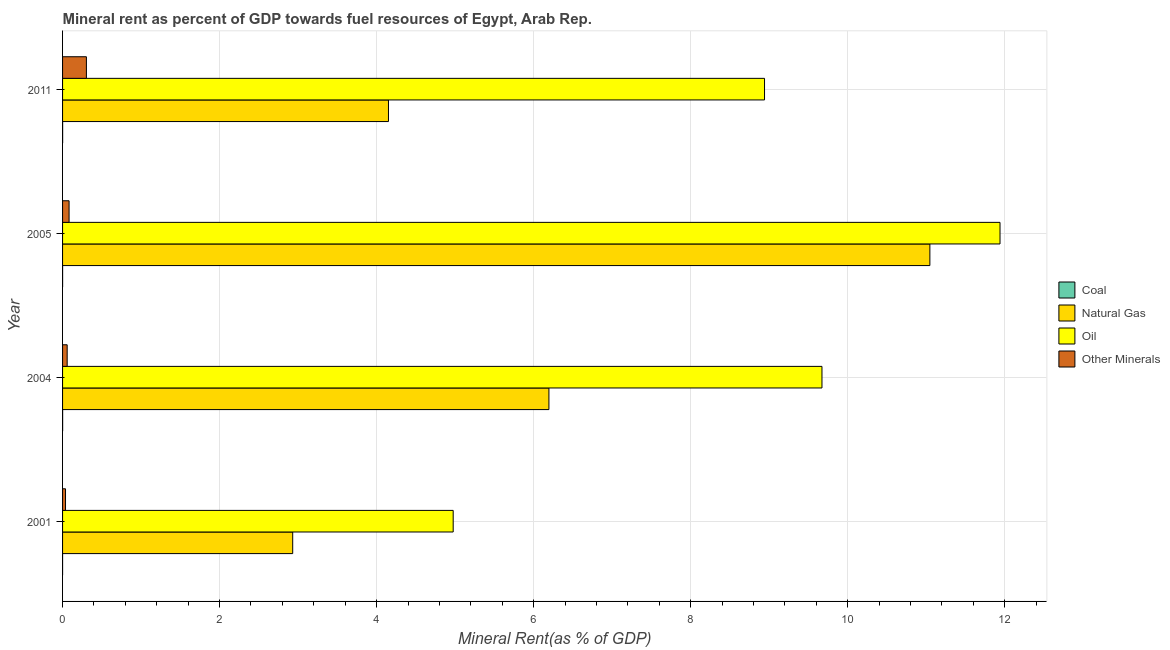How many different coloured bars are there?
Your response must be concise. 4. Are the number of bars per tick equal to the number of legend labels?
Make the answer very short. Yes. Are the number of bars on each tick of the Y-axis equal?
Offer a terse response. Yes. In how many cases, is the number of bars for a given year not equal to the number of legend labels?
Your answer should be compact. 0. What is the  rent of other minerals in 2004?
Offer a very short reply. 0.06. Across all years, what is the maximum natural gas rent?
Your answer should be compact. 11.05. Across all years, what is the minimum oil rent?
Give a very brief answer. 4.98. In which year was the natural gas rent minimum?
Offer a very short reply. 2001. What is the total oil rent in the graph?
Your response must be concise. 35.53. What is the difference between the coal rent in 2001 and that in 2011?
Make the answer very short. -0. What is the difference between the  rent of other minerals in 2001 and the natural gas rent in 2011?
Your response must be concise. -4.11. What is the average coal rent per year?
Your answer should be very brief. 0. In the year 2011, what is the difference between the coal rent and natural gas rent?
Give a very brief answer. -4.15. In how many years, is the coal rent greater than 9.2 %?
Your answer should be very brief. 0. What is the ratio of the  rent of other minerals in 2004 to that in 2011?
Make the answer very short. 0.19. Is the oil rent in 2004 less than that in 2005?
Your answer should be compact. Yes. What is the difference between the highest and the second highest natural gas rent?
Make the answer very short. 4.85. What does the 1st bar from the top in 2011 represents?
Make the answer very short. Other Minerals. What does the 1st bar from the bottom in 2001 represents?
Keep it short and to the point. Coal. How many bars are there?
Give a very brief answer. 16. What is the difference between two consecutive major ticks on the X-axis?
Your response must be concise. 2. Does the graph contain any zero values?
Your answer should be very brief. No. Does the graph contain grids?
Keep it short and to the point. Yes. How many legend labels are there?
Provide a short and direct response. 4. What is the title of the graph?
Make the answer very short. Mineral rent as percent of GDP towards fuel resources of Egypt, Arab Rep. Does "Secondary vocational education" appear as one of the legend labels in the graph?
Your answer should be very brief. No. What is the label or title of the X-axis?
Keep it short and to the point. Mineral Rent(as % of GDP). What is the label or title of the Y-axis?
Offer a terse response. Year. What is the Mineral Rent(as % of GDP) of Coal in 2001?
Provide a short and direct response. 1.02739128441411e-6. What is the Mineral Rent(as % of GDP) of Natural Gas in 2001?
Offer a terse response. 2.93. What is the Mineral Rent(as % of GDP) in Oil in 2001?
Ensure brevity in your answer.  4.98. What is the Mineral Rent(as % of GDP) in Other Minerals in 2001?
Keep it short and to the point. 0.04. What is the Mineral Rent(as % of GDP) in Coal in 2004?
Provide a short and direct response. 0. What is the Mineral Rent(as % of GDP) in Natural Gas in 2004?
Offer a very short reply. 6.19. What is the Mineral Rent(as % of GDP) in Oil in 2004?
Offer a terse response. 9.67. What is the Mineral Rent(as % of GDP) of Other Minerals in 2004?
Your answer should be very brief. 0.06. What is the Mineral Rent(as % of GDP) of Coal in 2005?
Your answer should be very brief. 0. What is the Mineral Rent(as % of GDP) in Natural Gas in 2005?
Provide a short and direct response. 11.05. What is the Mineral Rent(as % of GDP) in Oil in 2005?
Provide a succinct answer. 11.94. What is the Mineral Rent(as % of GDP) in Other Minerals in 2005?
Your answer should be very brief. 0.08. What is the Mineral Rent(as % of GDP) in Coal in 2011?
Make the answer very short. 0. What is the Mineral Rent(as % of GDP) of Natural Gas in 2011?
Your answer should be very brief. 4.15. What is the Mineral Rent(as % of GDP) of Oil in 2011?
Keep it short and to the point. 8.94. What is the Mineral Rent(as % of GDP) in Other Minerals in 2011?
Provide a succinct answer. 0.3. Across all years, what is the maximum Mineral Rent(as % of GDP) of Coal?
Offer a terse response. 0. Across all years, what is the maximum Mineral Rent(as % of GDP) in Natural Gas?
Make the answer very short. 11.05. Across all years, what is the maximum Mineral Rent(as % of GDP) in Oil?
Give a very brief answer. 11.94. Across all years, what is the maximum Mineral Rent(as % of GDP) of Other Minerals?
Your response must be concise. 0.3. Across all years, what is the minimum Mineral Rent(as % of GDP) of Coal?
Your answer should be compact. 1.02739128441411e-6. Across all years, what is the minimum Mineral Rent(as % of GDP) in Natural Gas?
Offer a very short reply. 2.93. Across all years, what is the minimum Mineral Rent(as % of GDP) of Oil?
Your answer should be compact. 4.98. Across all years, what is the minimum Mineral Rent(as % of GDP) in Other Minerals?
Provide a short and direct response. 0.04. What is the total Mineral Rent(as % of GDP) in Coal in the graph?
Provide a succinct answer. 0. What is the total Mineral Rent(as % of GDP) in Natural Gas in the graph?
Offer a terse response. 24.32. What is the total Mineral Rent(as % of GDP) in Oil in the graph?
Give a very brief answer. 35.53. What is the total Mineral Rent(as % of GDP) of Other Minerals in the graph?
Ensure brevity in your answer.  0.48. What is the difference between the Mineral Rent(as % of GDP) of Coal in 2001 and that in 2004?
Keep it short and to the point. -0. What is the difference between the Mineral Rent(as % of GDP) of Natural Gas in 2001 and that in 2004?
Your answer should be very brief. -3.26. What is the difference between the Mineral Rent(as % of GDP) in Oil in 2001 and that in 2004?
Make the answer very short. -4.7. What is the difference between the Mineral Rent(as % of GDP) in Other Minerals in 2001 and that in 2004?
Your answer should be very brief. -0.02. What is the difference between the Mineral Rent(as % of GDP) in Coal in 2001 and that in 2005?
Offer a very short reply. -0. What is the difference between the Mineral Rent(as % of GDP) in Natural Gas in 2001 and that in 2005?
Provide a short and direct response. -8.12. What is the difference between the Mineral Rent(as % of GDP) of Oil in 2001 and that in 2005?
Make the answer very short. -6.96. What is the difference between the Mineral Rent(as % of GDP) in Other Minerals in 2001 and that in 2005?
Offer a very short reply. -0.05. What is the difference between the Mineral Rent(as % of GDP) in Coal in 2001 and that in 2011?
Your answer should be very brief. -0. What is the difference between the Mineral Rent(as % of GDP) in Natural Gas in 2001 and that in 2011?
Make the answer very short. -1.22. What is the difference between the Mineral Rent(as % of GDP) in Oil in 2001 and that in 2011?
Give a very brief answer. -3.97. What is the difference between the Mineral Rent(as % of GDP) of Other Minerals in 2001 and that in 2011?
Your response must be concise. -0.27. What is the difference between the Mineral Rent(as % of GDP) of Coal in 2004 and that in 2005?
Your answer should be compact. 0. What is the difference between the Mineral Rent(as % of GDP) in Natural Gas in 2004 and that in 2005?
Your answer should be very brief. -4.85. What is the difference between the Mineral Rent(as % of GDP) of Oil in 2004 and that in 2005?
Ensure brevity in your answer.  -2.27. What is the difference between the Mineral Rent(as % of GDP) in Other Minerals in 2004 and that in 2005?
Keep it short and to the point. -0.02. What is the difference between the Mineral Rent(as % of GDP) in Natural Gas in 2004 and that in 2011?
Offer a very short reply. 2.04. What is the difference between the Mineral Rent(as % of GDP) of Oil in 2004 and that in 2011?
Your answer should be very brief. 0.73. What is the difference between the Mineral Rent(as % of GDP) in Other Minerals in 2004 and that in 2011?
Your answer should be compact. -0.24. What is the difference between the Mineral Rent(as % of GDP) in Coal in 2005 and that in 2011?
Your response must be concise. -0. What is the difference between the Mineral Rent(as % of GDP) of Natural Gas in 2005 and that in 2011?
Provide a succinct answer. 6.9. What is the difference between the Mineral Rent(as % of GDP) of Oil in 2005 and that in 2011?
Your response must be concise. 3. What is the difference between the Mineral Rent(as % of GDP) of Other Minerals in 2005 and that in 2011?
Give a very brief answer. -0.22. What is the difference between the Mineral Rent(as % of GDP) in Coal in 2001 and the Mineral Rent(as % of GDP) in Natural Gas in 2004?
Give a very brief answer. -6.19. What is the difference between the Mineral Rent(as % of GDP) of Coal in 2001 and the Mineral Rent(as % of GDP) of Oil in 2004?
Offer a terse response. -9.67. What is the difference between the Mineral Rent(as % of GDP) of Coal in 2001 and the Mineral Rent(as % of GDP) of Other Minerals in 2004?
Provide a succinct answer. -0.06. What is the difference between the Mineral Rent(as % of GDP) in Natural Gas in 2001 and the Mineral Rent(as % of GDP) in Oil in 2004?
Your answer should be very brief. -6.74. What is the difference between the Mineral Rent(as % of GDP) of Natural Gas in 2001 and the Mineral Rent(as % of GDP) of Other Minerals in 2004?
Keep it short and to the point. 2.87. What is the difference between the Mineral Rent(as % of GDP) in Oil in 2001 and the Mineral Rent(as % of GDP) in Other Minerals in 2004?
Offer a very short reply. 4.92. What is the difference between the Mineral Rent(as % of GDP) in Coal in 2001 and the Mineral Rent(as % of GDP) in Natural Gas in 2005?
Offer a terse response. -11.05. What is the difference between the Mineral Rent(as % of GDP) of Coal in 2001 and the Mineral Rent(as % of GDP) of Oil in 2005?
Keep it short and to the point. -11.94. What is the difference between the Mineral Rent(as % of GDP) of Coal in 2001 and the Mineral Rent(as % of GDP) of Other Minerals in 2005?
Your response must be concise. -0.08. What is the difference between the Mineral Rent(as % of GDP) in Natural Gas in 2001 and the Mineral Rent(as % of GDP) in Oil in 2005?
Keep it short and to the point. -9.01. What is the difference between the Mineral Rent(as % of GDP) of Natural Gas in 2001 and the Mineral Rent(as % of GDP) of Other Minerals in 2005?
Your answer should be compact. 2.85. What is the difference between the Mineral Rent(as % of GDP) of Oil in 2001 and the Mineral Rent(as % of GDP) of Other Minerals in 2005?
Offer a very short reply. 4.89. What is the difference between the Mineral Rent(as % of GDP) of Coal in 2001 and the Mineral Rent(as % of GDP) of Natural Gas in 2011?
Your response must be concise. -4.15. What is the difference between the Mineral Rent(as % of GDP) of Coal in 2001 and the Mineral Rent(as % of GDP) of Oil in 2011?
Make the answer very short. -8.94. What is the difference between the Mineral Rent(as % of GDP) of Coal in 2001 and the Mineral Rent(as % of GDP) of Other Minerals in 2011?
Offer a very short reply. -0.3. What is the difference between the Mineral Rent(as % of GDP) of Natural Gas in 2001 and the Mineral Rent(as % of GDP) of Oil in 2011?
Provide a succinct answer. -6.01. What is the difference between the Mineral Rent(as % of GDP) of Natural Gas in 2001 and the Mineral Rent(as % of GDP) of Other Minerals in 2011?
Give a very brief answer. 2.63. What is the difference between the Mineral Rent(as % of GDP) of Oil in 2001 and the Mineral Rent(as % of GDP) of Other Minerals in 2011?
Your response must be concise. 4.67. What is the difference between the Mineral Rent(as % of GDP) of Coal in 2004 and the Mineral Rent(as % of GDP) of Natural Gas in 2005?
Your answer should be very brief. -11.05. What is the difference between the Mineral Rent(as % of GDP) of Coal in 2004 and the Mineral Rent(as % of GDP) of Oil in 2005?
Ensure brevity in your answer.  -11.94. What is the difference between the Mineral Rent(as % of GDP) in Coal in 2004 and the Mineral Rent(as % of GDP) in Other Minerals in 2005?
Offer a very short reply. -0.08. What is the difference between the Mineral Rent(as % of GDP) in Natural Gas in 2004 and the Mineral Rent(as % of GDP) in Oil in 2005?
Offer a terse response. -5.75. What is the difference between the Mineral Rent(as % of GDP) of Natural Gas in 2004 and the Mineral Rent(as % of GDP) of Other Minerals in 2005?
Offer a terse response. 6.11. What is the difference between the Mineral Rent(as % of GDP) of Oil in 2004 and the Mineral Rent(as % of GDP) of Other Minerals in 2005?
Make the answer very short. 9.59. What is the difference between the Mineral Rent(as % of GDP) of Coal in 2004 and the Mineral Rent(as % of GDP) of Natural Gas in 2011?
Give a very brief answer. -4.15. What is the difference between the Mineral Rent(as % of GDP) in Coal in 2004 and the Mineral Rent(as % of GDP) in Oil in 2011?
Provide a short and direct response. -8.94. What is the difference between the Mineral Rent(as % of GDP) of Coal in 2004 and the Mineral Rent(as % of GDP) of Other Minerals in 2011?
Give a very brief answer. -0.3. What is the difference between the Mineral Rent(as % of GDP) in Natural Gas in 2004 and the Mineral Rent(as % of GDP) in Oil in 2011?
Offer a very short reply. -2.75. What is the difference between the Mineral Rent(as % of GDP) of Natural Gas in 2004 and the Mineral Rent(as % of GDP) of Other Minerals in 2011?
Make the answer very short. 5.89. What is the difference between the Mineral Rent(as % of GDP) of Oil in 2004 and the Mineral Rent(as % of GDP) of Other Minerals in 2011?
Offer a very short reply. 9.37. What is the difference between the Mineral Rent(as % of GDP) of Coal in 2005 and the Mineral Rent(as % of GDP) of Natural Gas in 2011?
Provide a succinct answer. -4.15. What is the difference between the Mineral Rent(as % of GDP) of Coal in 2005 and the Mineral Rent(as % of GDP) of Oil in 2011?
Offer a terse response. -8.94. What is the difference between the Mineral Rent(as % of GDP) in Coal in 2005 and the Mineral Rent(as % of GDP) in Other Minerals in 2011?
Offer a terse response. -0.3. What is the difference between the Mineral Rent(as % of GDP) in Natural Gas in 2005 and the Mineral Rent(as % of GDP) in Oil in 2011?
Make the answer very short. 2.11. What is the difference between the Mineral Rent(as % of GDP) in Natural Gas in 2005 and the Mineral Rent(as % of GDP) in Other Minerals in 2011?
Your response must be concise. 10.74. What is the difference between the Mineral Rent(as % of GDP) of Oil in 2005 and the Mineral Rent(as % of GDP) of Other Minerals in 2011?
Make the answer very short. 11.64. What is the average Mineral Rent(as % of GDP) in Natural Gas per year?
Your answer should be compact. 6.08. What is the average Mineral Rent(as % of GDP) in Oil per year?
Give a very brief answer. 8.88. What is the average Mineral Rent(as % of GDP) of Other Minerals per year?
Give a very brief answer. 0.12. In the year 2001, what is the difference between the Mineral Rent(as % of GDP) in Coal and Mineral Rent(as % of GDP) in Natural Gas?
Provide a succinct answer. -2.93. In the year 2001, what is the difference between the Mineral Rent(as % of GDP) of Coal and Mineral Rent(as % of GDP) of Oil?
Your response must be concise. -4.98. In the year 2001, what is the difference between the Mineral Rent(as % of GDP) of Coal and Mineral Rent(as % of GDP) of Other Minerals?
Your answer should be very brief. -0.04. In the year 2001, what is the difference between the Mineral Rent(as % of GDP) in Natural Gas and Mineral Rent(as % of GDP) in Oil?
Your response must be concise. -2.04. In the year 2001, what is the difference between the Mineral Rent(as % of GDP) of Natural Gas and Mineral Rent(as % of GDP) of Other Minerals?
Your answer should be very brief. 2.89. In the year 2001, what is the difference between the Mineral Rent(as % of GDP) of Oil and Mineral Rent(as % of GDP) of Other Minerals?
Your response must be concise. 4.94. In the year 2004, what is the difference between the Mineral Rent(as % of GDP) of Coal and Mineral Rent(as % of GDP) of Natural Gas?
Your answer should be compact. -6.19. In the year 2004, what is the difference between the Mineral Rent(as % of GDP) in Coal and Mineral Rent(as % of GDP) in Oil?
Provide a succinct answer. -9.67. In the year 2004, what is the difference between the Mineral Rent(as % of GDP) in Coal and Mineral Rent(as % of GDP) in Other Minerals?
Offer a very short reply. -0.06. In the year 2004, what is the difference between the Mineral Rent(as % of GDP) in Natural Gas and Mineral Rent(as % of GDP) in Oil?
Give a very brief answer. -3.48. In the year 2004, what is the difference between the Mineral Rent(as % of GDP) of Natural Gas and Mineral Rent(as % of GDP) of Other Minerals?
Your answer should be compact. 6.14. In the year 2004, what is the difference between the Mineral Rent(as % of GDP) of Oil and Mineral Rent(as % of GDP) of Other Minerals?
Offer a very short reply. 9.61. In the year 2005, what is the difference between the Mineral Rent(as % of GDP) of Coal and Mineral Rent(as % of GDP) of Natural Gas?
Give a very brief answer. -11.05. In the year 2005, what is the difference between the Mineral Rent(as % of GDP) in Coal and Mineral Rent(as % of GDP) in Oil?
Provide a short and direct response. -11.94. In the year 2005, what is the difference between the Mineral Rent(as % of GDP) of Coal and Mineral Rent(as % of GDP) of Other Minerals?
Keep it short and to the point. -0.08. In the year 2005, what is the difference between the Mineral Rent(as % of GDP) in Natural Gas and Mineral Rent(as % of GDP) in Oil?
Ensure brevity in your answer.  -0.89. In the year 2005, what is the difference between the Mineral Rent(as % of GDP) in Natural Gas and Mineral Rent(as % of GDP) in Other Minerals?
Your answer should be compact. 10.96. In the year 2005, what is the difference between the Mineral Rent(as % of GDP) in Oil and Mineral Rent(as % of GDP) in Other Minerals?
Your answer should be compact. 11.86. In the year 2011, what is the difference between the Mineral Rent(as % of GDP) of Coal and Mineral Rent(as % of GDP) of Natural Gas?
Your answer should be very brief. -4.15. In the year 2011, what is the difference between the Mineral Rent(as % of GDP) of Coal and Mineral Rent(as % of GDP) of Oil?
Keep it short and to the point. -8.94. In the year 2011, what is the difference between the Mineral Rent(as % of GDP) in Coal and Mineral Rent(as % of GDP) in Other Minerals?
Offer a terse response. -0.3. In the year 2011, what is the difference between the Mineral Rent(as % of GDP) of Natural Gas and Mineral Rent(as % of GDP) of Oil?
Provide a short and direct response. -4.79. In the year 2011, what is the difference between the Mineral Rent(as % of GDP) in Natural Gas and Mineral Rent(as % of GDP) in Other Minerals?
Ensure brevity in your answer.  3.85. In the year 2011, what is the difference between the Mineral Rent(as % of GDP) of Oil and Mineral Rent(as % of GDP) of Other Minerals?
Offer a terse response. 8.64. What is the ratio of the Mineral Rent(as % of GDP) in Coal in 2001 to that in 2004?
Ensure brevity in your answer.  0. What is the ratio of the Mineral Rent(as % of GDP) in Natural Gas in 2001 to that in 2004?
Your response must be concise. 0.47. What is the ratio of the Mineral Rent(as % of GDP) of Oil in 2001 to that in 2004?
Your answer should be very brief. 0.51. What is the ratio of the Mineral Rent(as % of GDP) in Other Minerals in 2001 to that in 2004?
Provide a short and direct response. 0.64. What is the ratio of the Mineral Rent(as % of GDP) of Coal in 2001 to that in 2005?
Your answer should be very brief. 0. What is the ratio of the Mineral Rent(as % of GDP) of Natural Gas in 2001 to that in 2005?
Keep it short and to the point. 0.27. What is the ratio of the Mineral Rent(as % of GDP) in Oil in 2001 to that in 2005?
Your response must be concise. 0.42. What is the ratio of the Mineral Rent(as % of GDP) of Other Minerals in 2001 to that in 2005?
Your answer should be very brief. 0.45. What is the ratio of the Mineral Rent(as % of GDP) in Coal in 2001 to that in 2011?
Ensure brevity in your answer.  0. What is the ratio of the Mineral Rent(as % of GDP) in Natural Gas in 2001 to that in 2011?
Provide a short and direct response. 0.71. What is the ratio of the Mineral Rent(as % of GDP) of Oil in 2001 to that in 2011?
Give a very brief answer. 0.56. What is the ratio of the Mineral Rent(as % of GDP) in Other Minerals in 2001 to that in 2011?
Offer a terse response. 0.12. What is the ratio of the Mineral Rent(as % of GDP) in Coal in 2004 to that in 2005?
Your response must be concise. 2.83. What is the ratio of the Mineral Rent(as % of GDP) in Natural Gas in 2004 to that in 2005?
Your answer should be compact. 0.56. What is the ratio of the Mineral Rent(as % of GDP) in Oil in 2004 to that in 2005?
Keep it short and to the point. 0.81. What is the ratio of the Mineral Rent(as % of GDP) in Other Minerals in 2004 to that in 2005?
Provide a short and direct response. 0.71. What is the ratio of the Mineral Rent(as % of GDP) in Coal in 2004 to that in 2011?
Keep it short and to the point. 1.13. What is the ratio of the Mineral Rent(as % of GDP) in Natural Gas in 2004 to that in 2011?
Provide a short and direct response. 1.49. What is the ratio of the Mineral Rent(as % of GDP) of Oil in 2004 to that in 2011?
Give a very brief answer. 1.08. What is the ratio of the Mineral Rent(as % of GDP) in Other Minerals in 2004 to that in 2011?
Offer a terse response. 0.19. What is the ratio of the Mineral Rent(as % of GDP) of Coal in 2005 to that in 2011?
Provide a short and direct response. 0.4. What is the ratio of the Mineral Rent(as % of GDP) of Natural Gas in 2005 to that in 2011?
Your response must be concise. 2.66. What is the ratio of the Mineral Rent(as % of GDP) of Oil in 2005 to that in 2011?
Give a very brief answer. 1.34. What is the ratio of the Mineral Rent(as % of GDP) in Other Minerals in 2005 to that in 2011?
Your answer should be compact. 0.27. What is the difference between the highest and the second highest Mineral Rent(as % of GDP) of Natural Gas?
Your answer should be very brief. 4.85. What is the difference between the highest and the second highest Mineral Rent(as % of GDP) of Oil?
Ensure brevity in your answer.  2.27. What is the difference between the highest and the second highest Mineral Rent(as % of GDP) in Other Minerals?
Give a very brief answer. 0.22. What is the difference between the highest and the lowest Mineral Rent(as % of GDP) in Coal?
Offer a terse response. 0. What is the difference between the highest and the lowest Mineral Rent(as % of GDP) in Natural Gas?
Keep it short and to the point. 8.12. What is the difference between the highest and the lowest Mineral Rent(as % of GDP) in Oil?
Ensure brevity in your answer.  6.96. What is the difference between the highest and the lowest Mineral Rent(as % of GDP) in Other Minerals?
Your response must be concise. 0.27. 